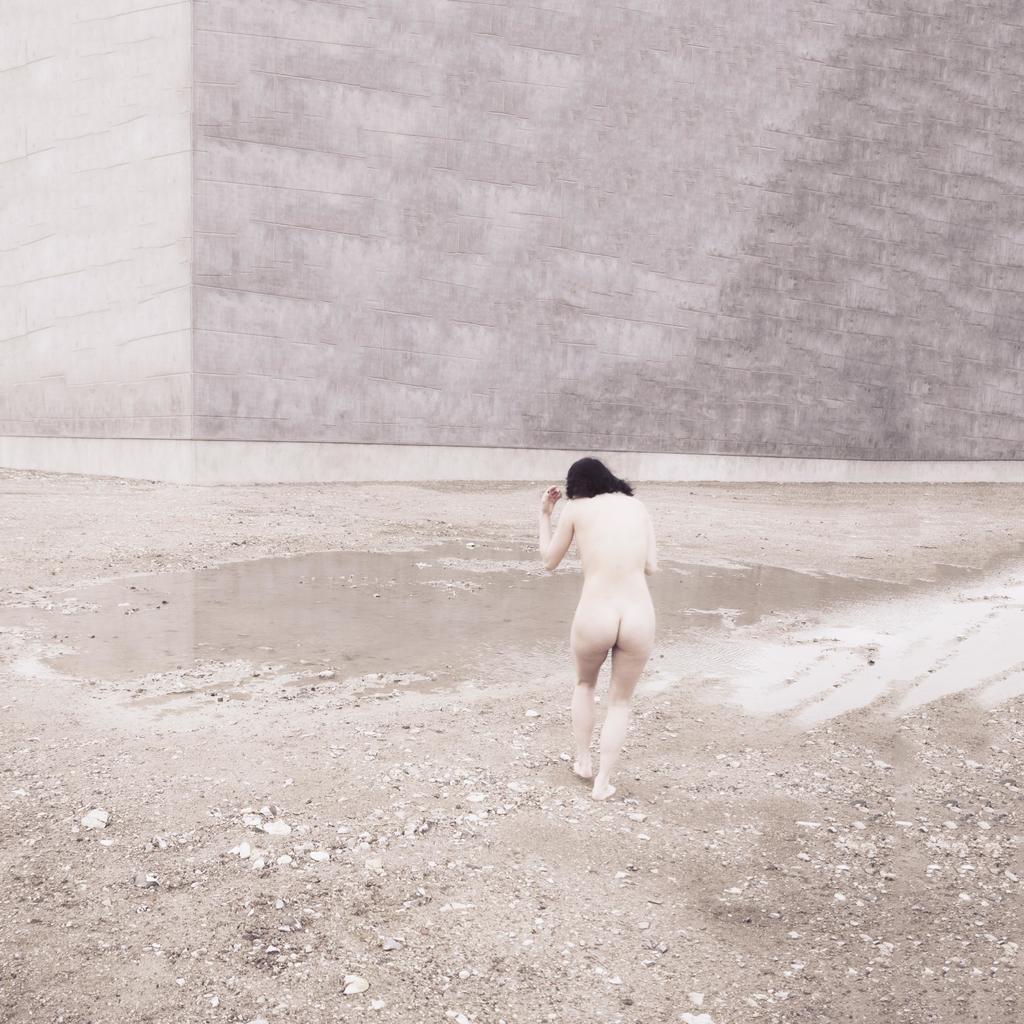Could you give a brief overview of what you see in this image? In this picture I can see there is woman, she is walking and there is soil and rocks here and there is a wall in the backdrop. 